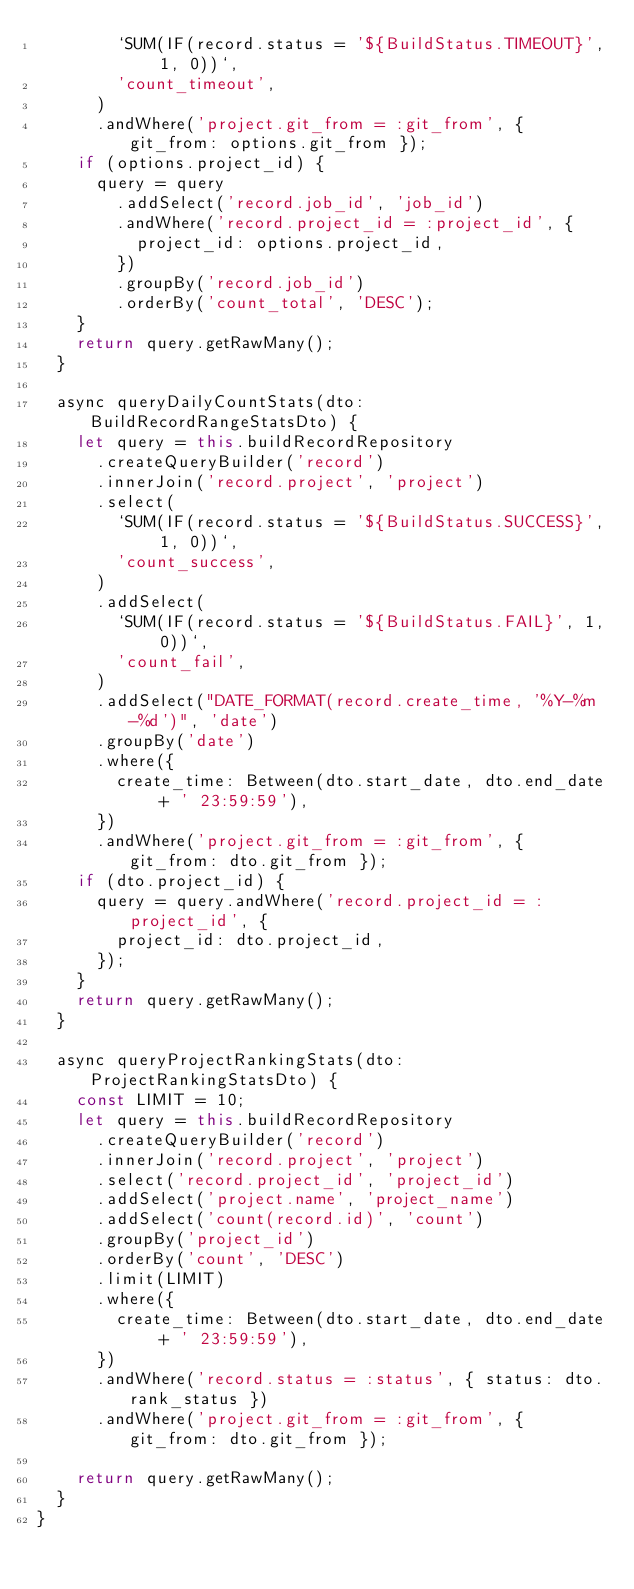Convert code to text. <code><loc_0><loc_0><loc_500><loc_500><_TypeScript_>        `SUM(IF(record.status = '${BuildStatus.TIMEOUT}', 1, 0))`,
        'count_timeout',
      )
      .andWhere('project.git_from = :git_from', { git_from: options.git_from });
    if (options.project_id) {
      query = query
        .addSelect('record.job_id', 'job_id')
        .andWhere('record.project_id = :project_id', {
          project_id: options.project_id,
        })
        .groupBy('record.job_id')
        .orderBy('count_total', 'DESC');
    }
    return query.getRawMany();
  }

  async queryDailyCountStats(dto: BuildRecordRangeStatsDto) {
    let query = this.buildRecordRepository
      .createQueryBuilder('record')
      .innerJoin('record.project', 'project')
      .select(
        `SUM(IF(record.status = '${BuildStatus.SUCCESS}', 1, 0))`,
        'count_success',
      )
      .addSelect(
        `SUM(IF(record.status = '${BuildStatus.FAIL}', 1, 0))`,
        'count_fail',
      )
      .addSelect("DATE_FORMAT(record.create_time, '%Y-%m-%d')", 'date')
      .groupBy('date')
      .where({
        create_time: Between(dto.start_date, dto.end_date + ' 23:59:59'),
      })
      .andWhere('project.git_from = :git_from', { git_from: dto.git_from });
    if (dto.project_id) {
      query = query.andWhere('record.project_id = :project_id', {
        project_id: dto.project_id,
      });
    }
    return query.getRawMany();
  }

  async queryProjectRankingStats(dto: ProjectRankingStatsDto) {
    const LIMIT = 10;
    let query = this.buildRecordRepository
      .createQueryBuilder('record')
      .innerJoin('record.project', 'project')
      .select('record.project_id', 'project_id')
      .addSelect('project.name', 'project_name')
      .addSelect('count(record.id)', 'count')
      .groupBy('project_id')
      .orderBy('count', 'DESC')
      .limit(LIMIT)
      .where({
        create_time: Between(dto.start_date, dto.end_date + ' 23:59:59'),
      })
      .andWhere('record.status = :status', { status: dto.rank_status })
      .andWhere('project.git_from = :git_from', { git_from: dto.git_from });

    return query.getRawMany();
  }
}
</code> 